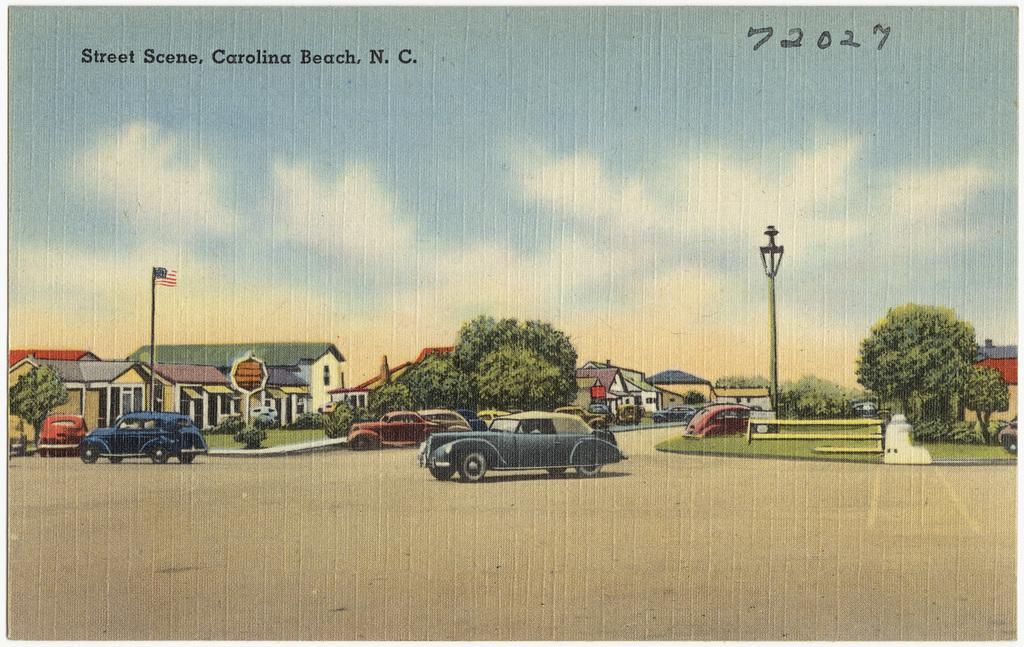How would you summarize this image in a sentence or two? In this image there is a painting. In the painting there are buildings, trees, few vehicles are moving on the road, a flag and a street light. In the background there is the sky and at the top of the image there is some text. 